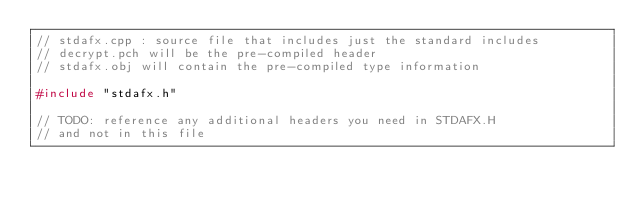<code> <loc_0><loc_0><loc_500><loc_500><_C++_>// stdafx.cpp : source file that includes just the standard includes
// decrypt.pch will be the pre-compiled header
// stdafx.obj will contain the pre-compiled type information

#include "stdafx.h"

// TODO: reference any additional headers you need in STDAFX.H
// and not in this file
</code> 